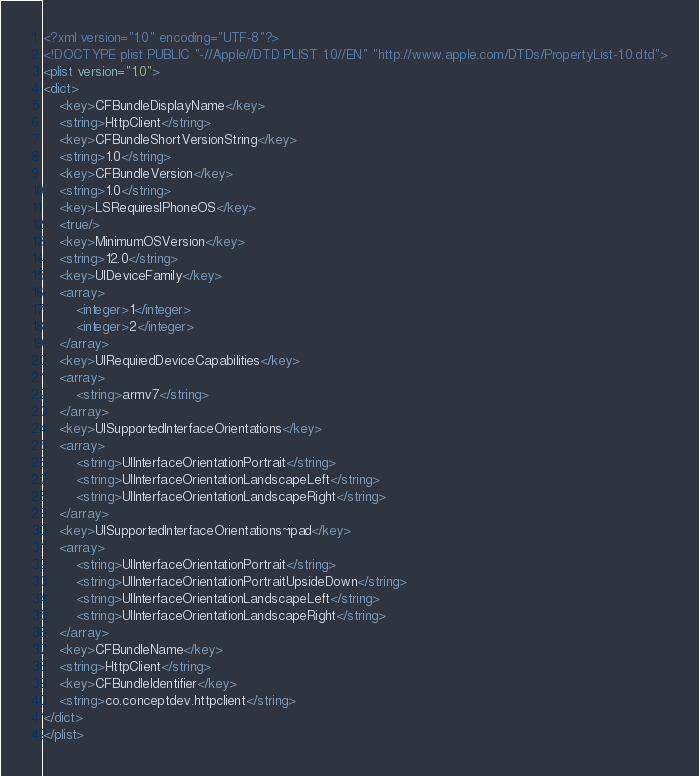Convert code to text. <code><loc_0><loc_0><loc_500><loc_500><_XML_><?xml version="1.0" encoding="UTF-8"?>
<!DOCTYPE plist PUBLIC "-//Apple//DTD PLIST 1.0//EN" "http://www.apple.com/DTDs/PropertyList-1.0.dtd">
<plist version="1.0">
<dict>
	<key>CFBundleDisplayName</key>
	<string>HttpClient</string>
	<key>CFBundleShortVersionString</key>
	<string>1.0</string>
	<key>CFBundleVersion</key>
	<string>1.0</string>
	<key>LSRequiresIPhoneOS</key>
	<true/>
	<key>MinimumOSVersion</key>
	<string>12.0</string>
	<key>UIDeviceFamily</key>
	<array>
		<integer>1</integer>
		<integer>2</integer>
	</array>
	<key>UIRequiredDeviceCapabilities</key>
	<array>
		<string>armv7</string>
	</array>
	<key>UISupportedInterfaceOrientations</key>
	<array>
		<string>UIInterfaceOrientationPortrait</string>
		<string>UIInterfaceOrientationLandscapeLeft</string>
		<string>UIInterfaceOrientationLandscapeRight</string>
	</array>
	<key>UISupportedInterfaceOrientations~ipad</key>
	<array>
		<string>UIInterfaceOrientationPortrait</string>
		<string>UIInterfaceOrientationPortraitUpsideDown</string>
		<string>UIInterfaceOrientationLandscapeLeft</string>
		<string>UIInterfaceOrientationLandscapeRight</string>
	</array>
	<key>CFBundleName</key>
	<string>HttpClient</string>
	<key>CFBundleIdentifier</key>
	<string>co.conceptdev.httpclient</string>
</dict>
</plist>
</code> 